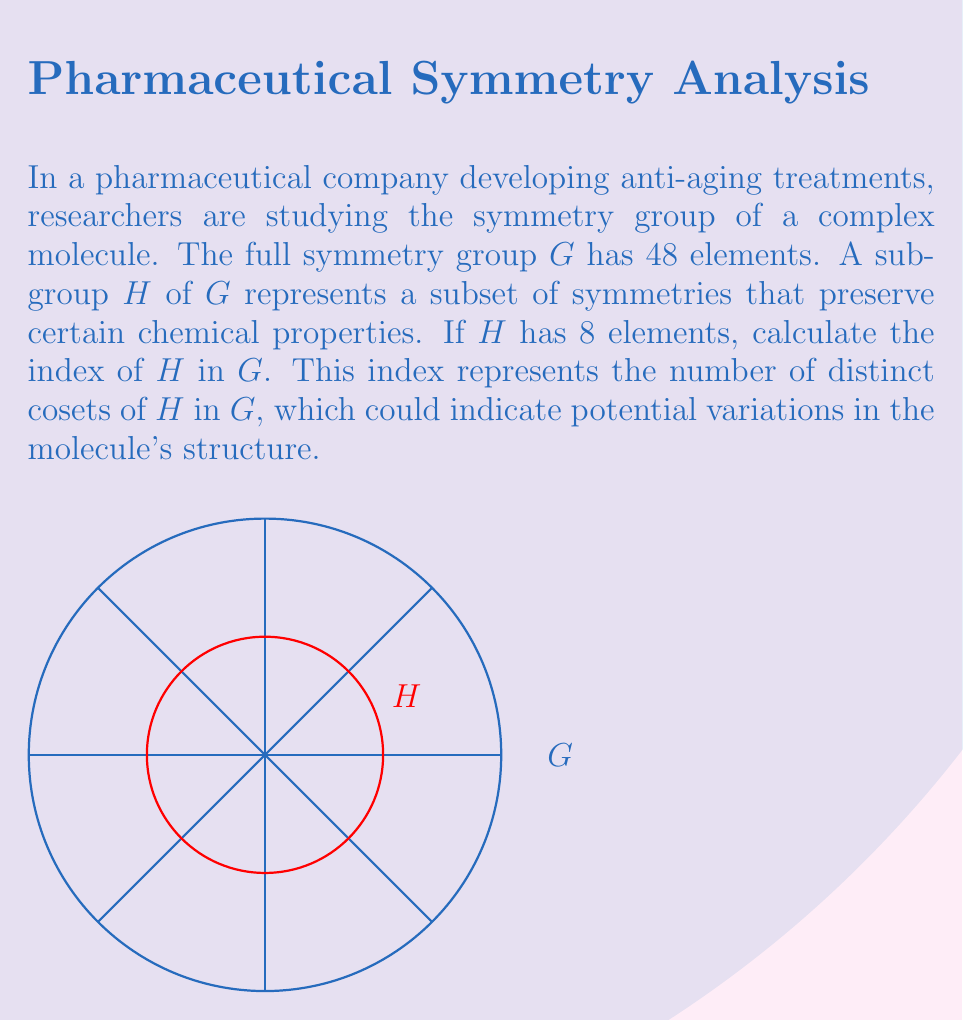Teach me how to tackle this problem. To calculate the index of subgroup $H$ in group $G$, we use the formula:

$$ [G:H] = \frac{|G|}{|H|} $$

Where:
- $[G:H]$ is the index of $H$ in $G$
- $|G|$ is the order (number of elements) of group $G$
- $|H|$ is the order of subgroup $H$

Given:
- $|G| = 48$ (full symmetry group)
- $|H| = 8$ (subgroup preserving certain properties)

Substituting these values into the formula:

$$ [G:H] = \frac{48}{8} = 6 $$

The index of $H$ in $G$ is 6, meaning there are 6 distinct cosets of $H$ in $G$.

This result indicates that the molecule's symmetries can be partitioned into 6 equivalent classes, each represented by a coset of $H$. These classes might correspond to different structural configurations or orientations of the molecule that are relevant to its anti-aging properties.
Answer: 6 